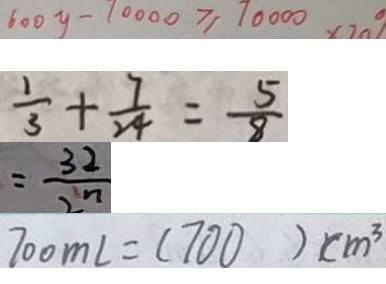<formula> <loc_0><loc_0><loc_500><loc_500>6 0 0 y - 1 0 0 0 0 \geq 1 0 0 0 0 
 \frac { 1 } { 3 } + \frac { 7 } { 2 4 } = \frac { 5 } { 8 } 
 = \frac { 3 2 } { 2 n } 
 7 0 0 m l = 1 7 0 0 ) c m ^ { 3 }</formula> 